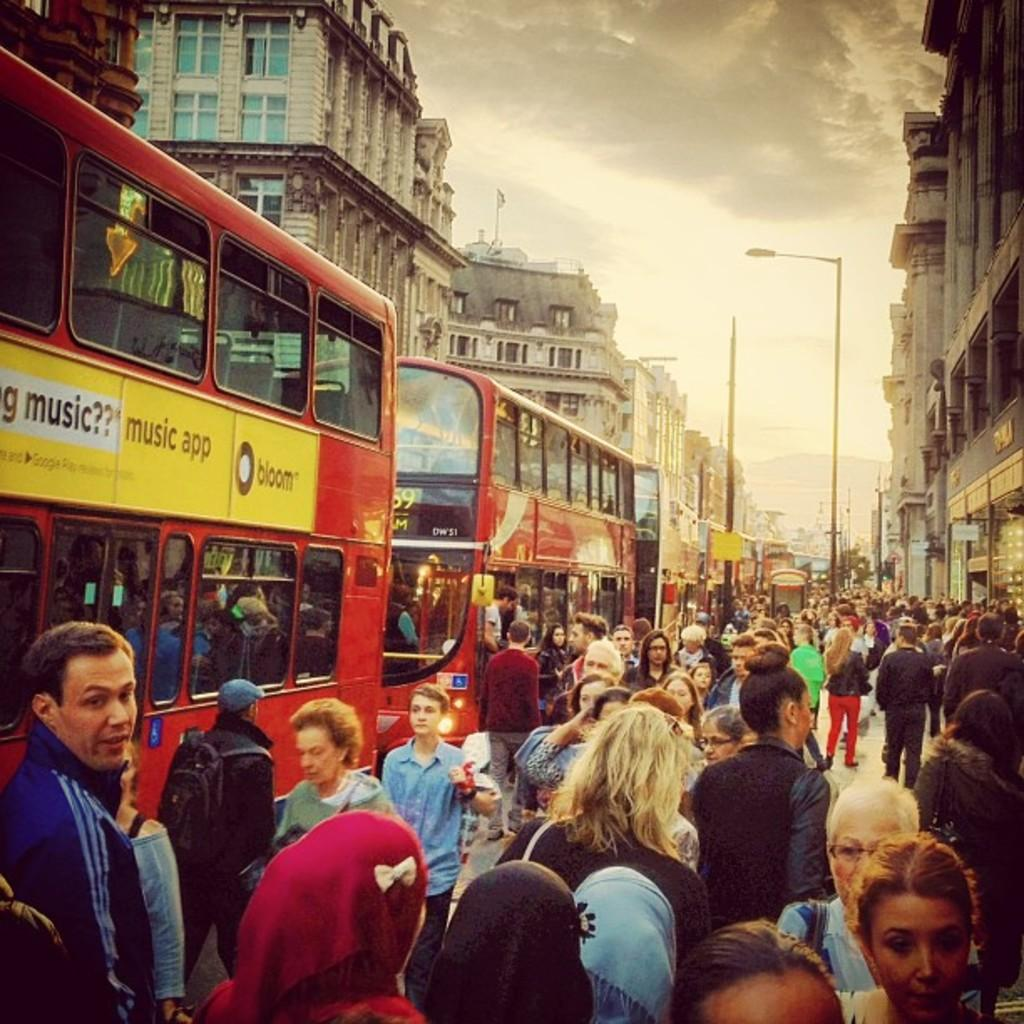<image>
Write a terse but informative summary of the picture. A double decker bus, with a advertisment that says music app 